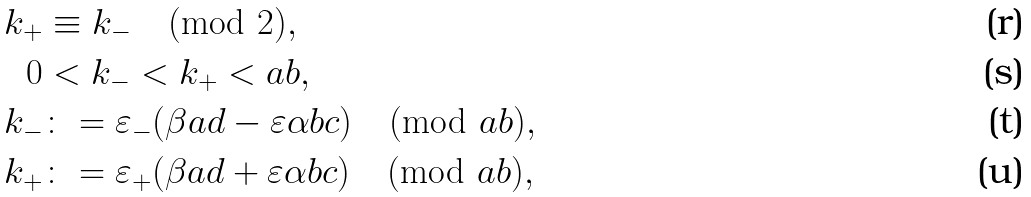<formula> <loc_0><loc_0><loc_500><loc_500>k _ { + } & \equiv k _ { - } \pmod { 2 } , \\ 0 & < k _ { - } < k _ { + } < a b , \\ k _ { - } & \colon = \varepsilon _ { - } ( \beta a d - \varepsilon \alpha b c ) \pmod { a b } , \\ k _ { + } & \colon = \varepsilon _ { + } ( \beta a d + \varepsilon \alpha b c ) \pmod { a b } ,</formula> 